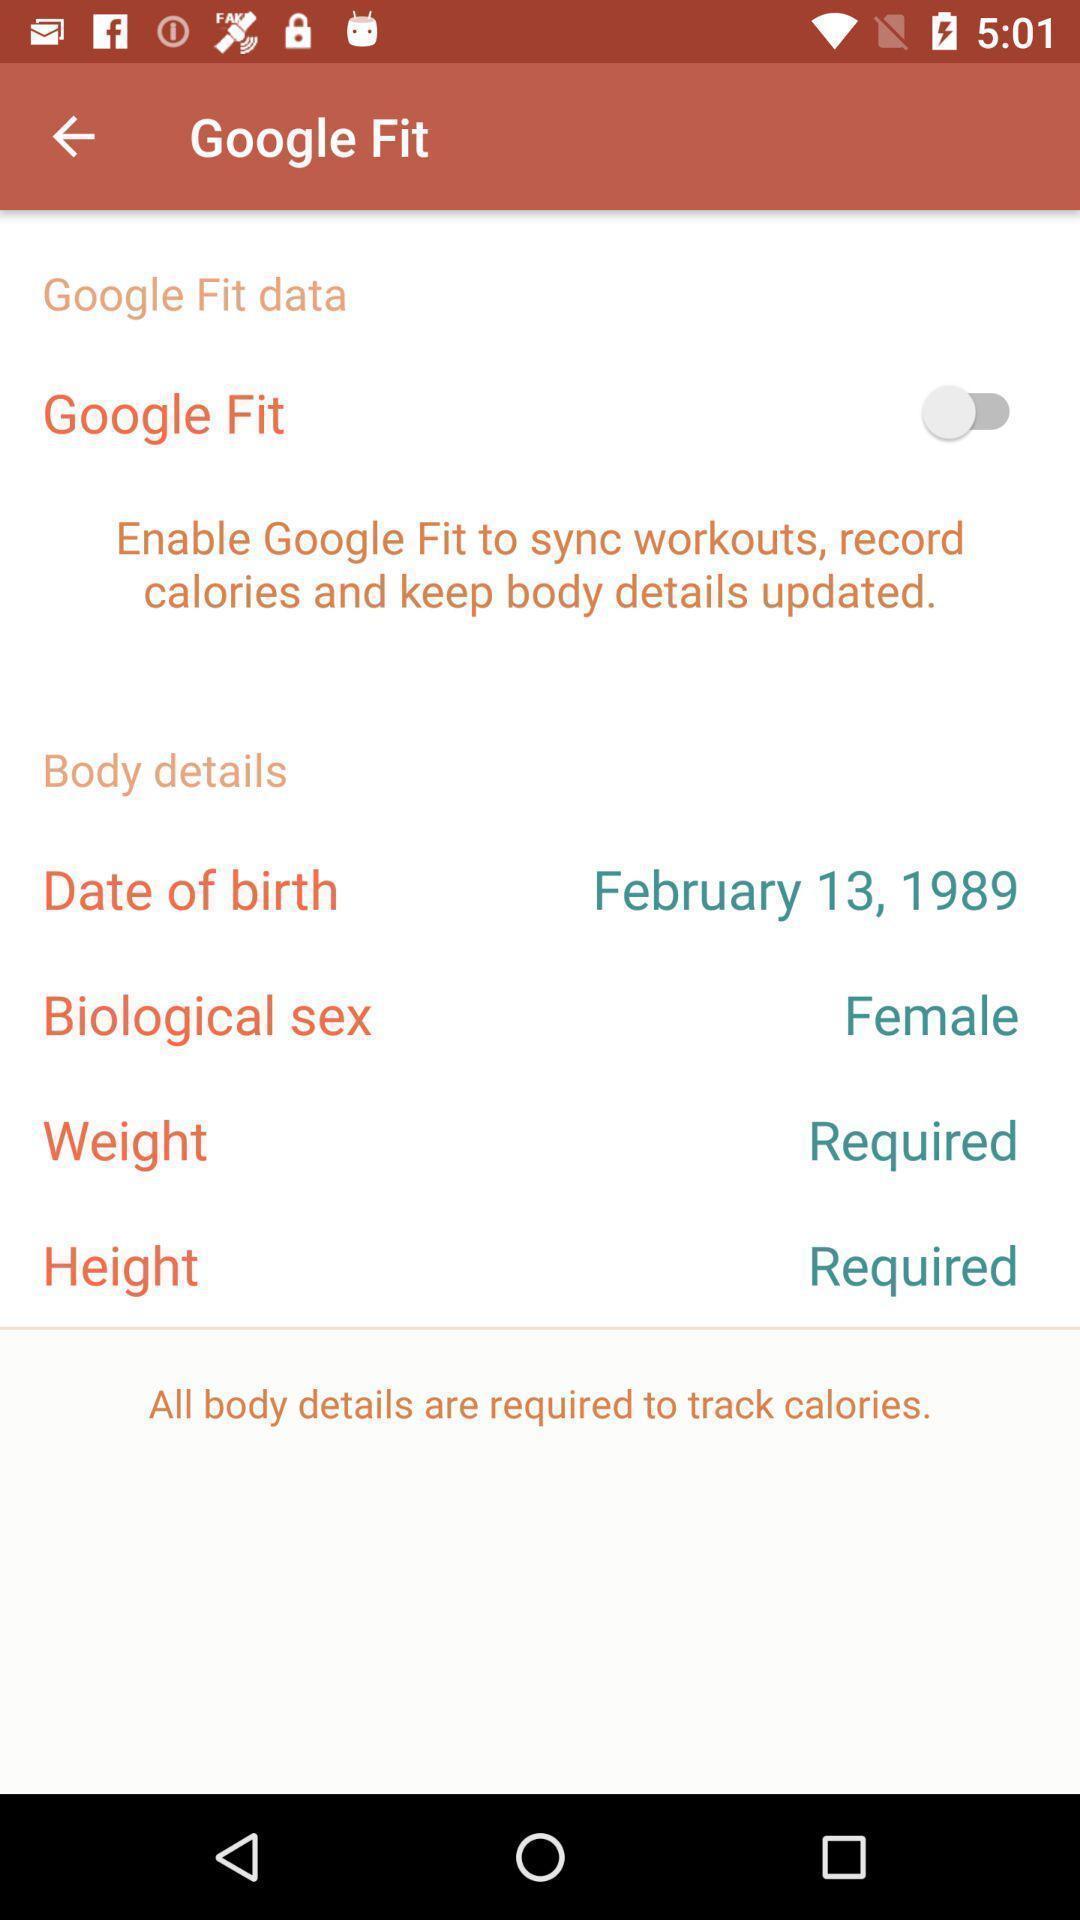Provide a detailed account of this screenshot. Screen shows body details of a female. 